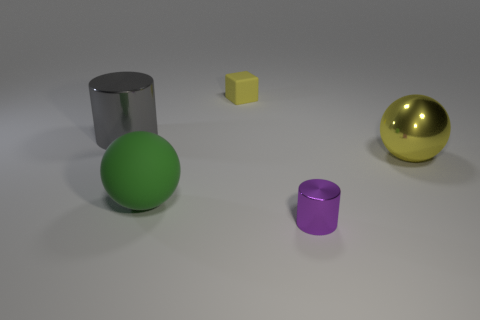Add 1 tiny purple metal cylinders. How many objects exist? 6 Subtract all cylinders. How many objects are left? 3 Add 4 gray cylinders. How many gray cylinders exist? 5 Subtract 1 yellow blocks. How many objects are left? 4 Subtract all green rubber things. Subtract all small cylinders. How many objects are left? 3 Add 5 tiny matte cubes. How many tiny matte cubes are left? 6 